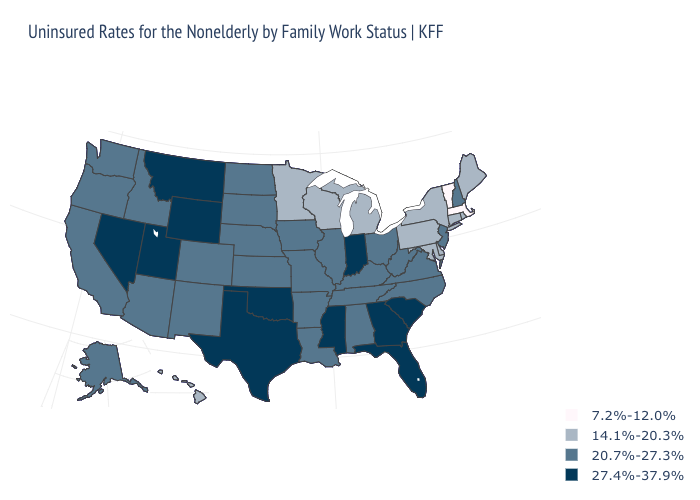What is the value of Delaware?
Short answer required. 14.1%-20.3%. Name the states that have a value in the range 14.1%-20.3%?
Concise answer only. Connecticut, Delaware, Hawaii, Maine, Maryland, Michigan, Minnesota, New York, Pennsylvania, Rhode Island, Wisconsin. What is the highest value in states that border Indiana?
Quick response, please. 20.7%-27.3%. What is the lowest value in states that border Connecticut?
Give a very brief answer. 7.2%-12.0%. What is the value of Montana?
Concise answer only. 27.4%-37.9%. Which states hav the highest value in the Northeast?
Write a very short answer. New Hampshire, New Jersey. Name the states that have a value in the range 20.7%-27.3%?
Short answer required. Alabama, Alaska, Arizona, Arkansas, California, Colorado, Idaho, Illinois, Iowa, Kansas, Kentucky, Louisiana, Missouri, Nebraska, New Hampshire, New Jersey, New Mexico, North Carolina, North Dakota, Ohio, Oregon, South Dakota, Tennessee, Virginia, Washington, West Virginia. What is the value of New Mexico?
Short answer required. 20.7%-27.3%. Name the states that have a value in the range 14.1%-20.3%?
Quick response, please. Connecticut, Delaware, Hawaii, Maine, Maryland, Michigan, Minnesota, New York, Pennsylvania, Rhode Island, Wisconsin. Which states have the lowest value in the Northeast?
Keep it brief. Massachusetts, Vermont. What is the highest value in the South ?
Short answer required. 27.4%-37.9%. Name the states that have a value in the range 20.7%-27.3%?
Answer briefly. Alabama, Alaska, Arizona, Arkansas, California, Colorado, Idaho, Illinois, Iowa, Kansas, Kentucky, Louisiana, Missouri, Nebraska, New Hampshire, New Jersey, New Mexico, North Carolina, North Dakota, Ohio, Oregon, South Dakota, Tennessee, Virginia, Washington, West Virginia. What is the value of New Mexico?
Concise answer only. 20.7%-27.3%. Name the states that have a value in the range 14.1%-20.3%?
Be succinct. Connecticut, Delaware, Hawaii, Maine, Maryland, Michigan, Minnesota, New York, Pennsylvania, Rhode Island, Wisconsin. Among the states that border Connecticut , which have the highest value?
Keep it brief. New York, Rhode Island. 